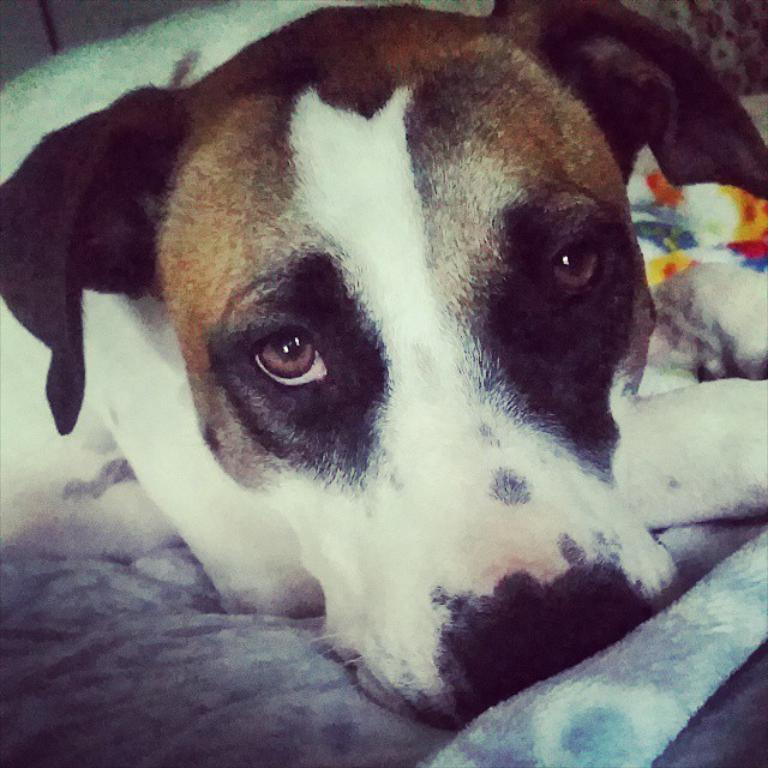What animal can be seen in the image? There is a dog in the image. What is the dog doing in the image? The dog is lying on a quilt. How tall is the giraffe in the image? There is no giraffe present in the image; it features a dog lying on a quilt. What type of camera was used to take the picture? The facts provided do not mention the camera used to take the picture, so we cannot determine the type of camera used. 